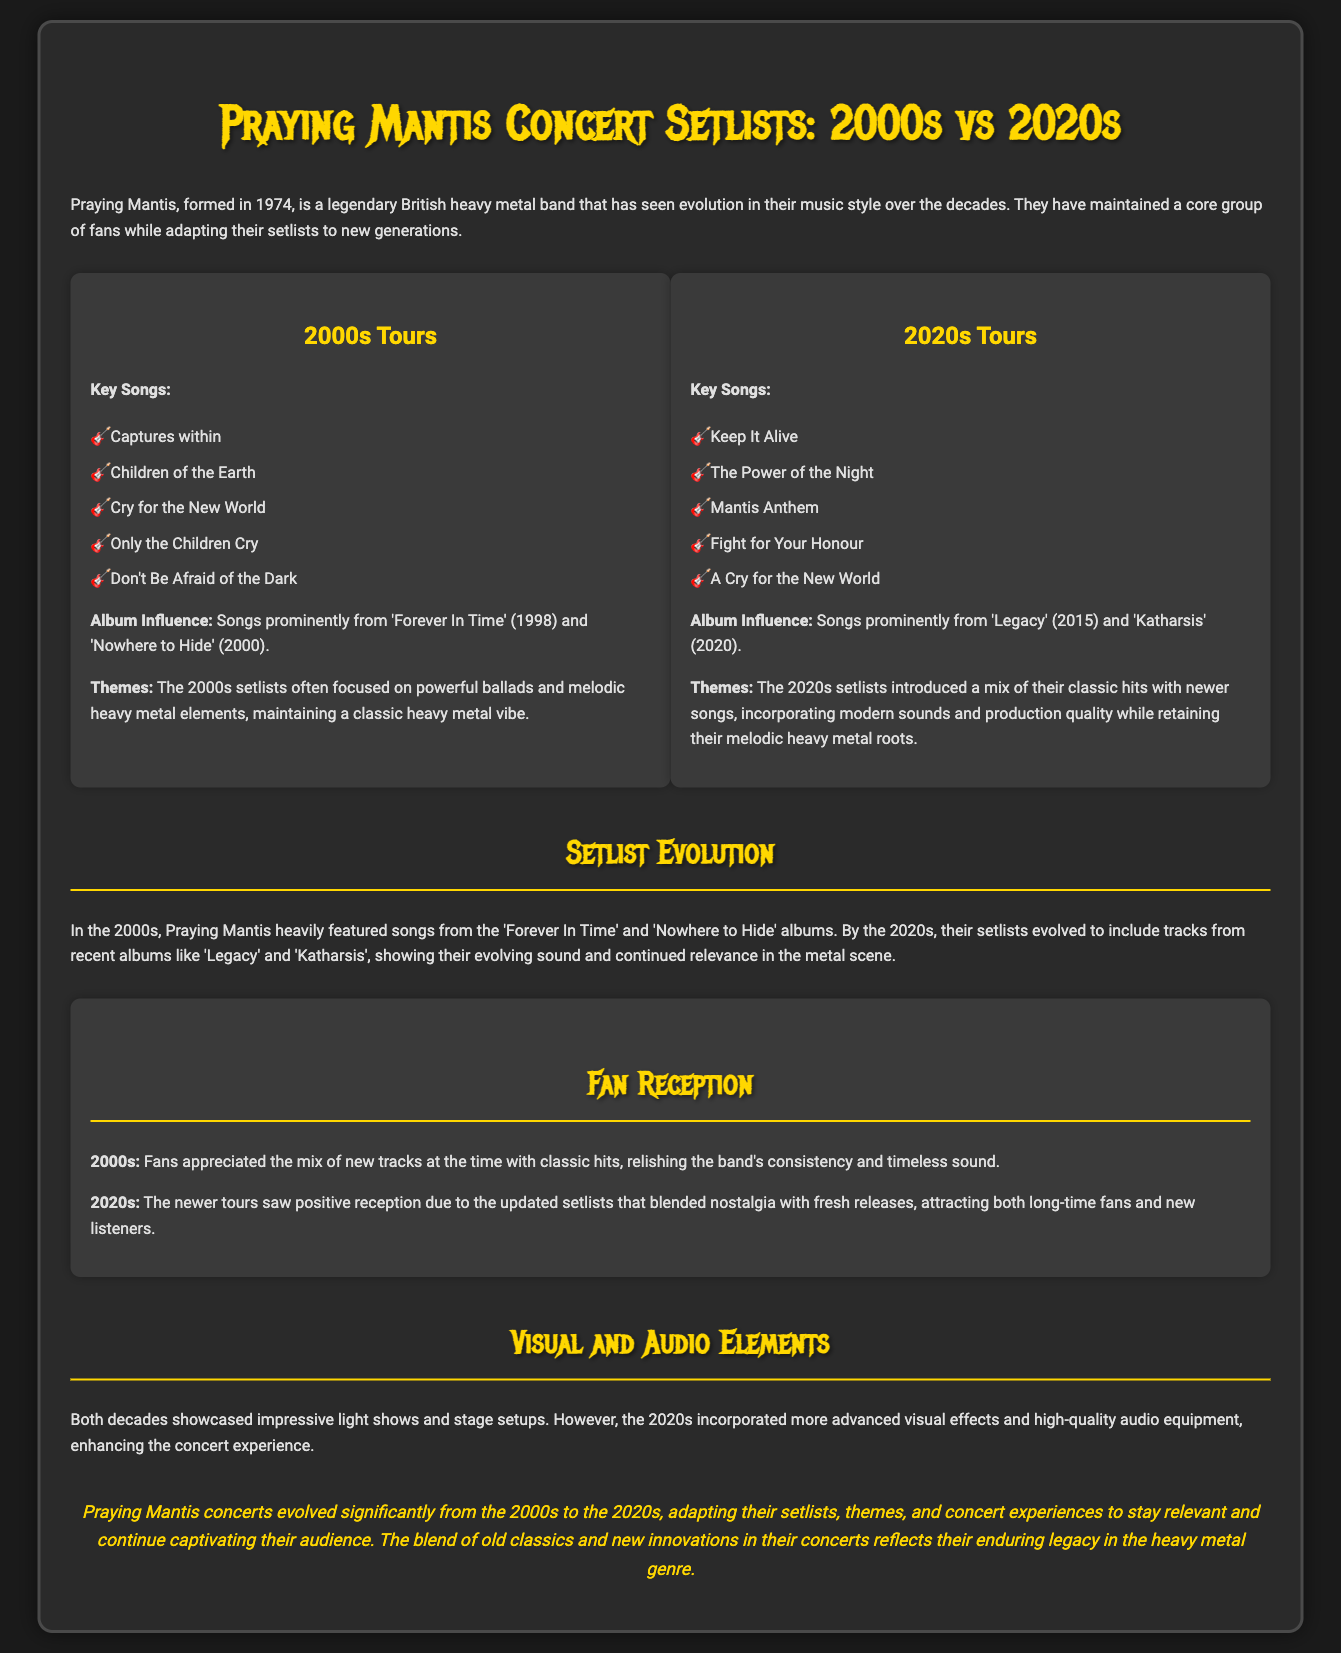What are the key songs from the 2000s tours? The document lists five key songs performed during the 2000s tours in the setlist section.
Answer: Captures within, Children of the Earth, Cry for the New World, Only the Children Cry, Don't Be Afraid of the Dark Which album influenced the 2020s setlists? The document mentions significant albums that influenced the songs in the 2020s tours.
Answer: Legacy, Katharsis What themes characterized the 2000s setlists? The document describes the themes focusing on powerful ballads and melodic elements in the 2000s setlists.
Answer: Powerful ballads and melodic heavy metal elements How did fan reception differ between the 2000s and 2020s? The document outlines the fans' appreciation in two different decades, highlighting the reception's evolution.
Answer: Consistency vs. nostalgia with fresh releases What visual enhancements were noted in the 2020s concerts? The document compares visual and audio elements used in concerts across the two decades, pointing to advancements.
Answer: Advanced visual effects and high-quality audio equipment 